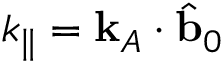Convert formula to latex. <formula><loc_0><loc_0><loc_500><loc_500>k _ { \| } = k _ { A } \cdot \hat { b } _ { 0 }</formula> 